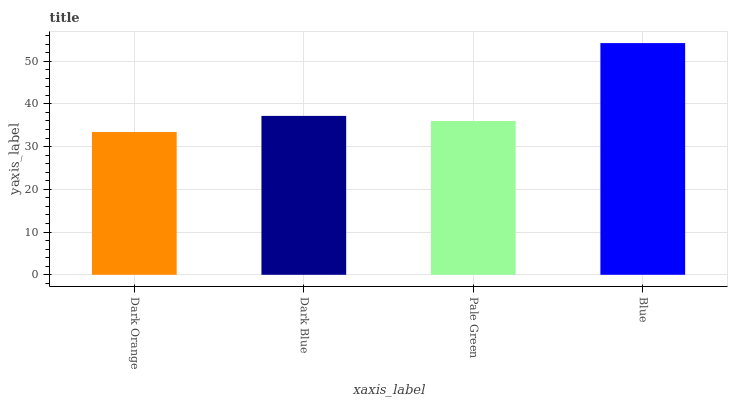Is Dark Orange the minimum?
Answer yes or no. Yes. Is Blue the maximum?
Answer yes or no. Yes. Is Dark Blue the minimum?
Answer yes or no. No. Is Dark Blue the maximum?
Answer yes or no. No. Is Dark Blue greater than Dark Orange?
Answer yes or no. Yes. Is Dark Orange less than Dark Blue?
Answer yes or no. Yes. Is Dark Orange greater than Dark Blue?
Answer yes or no. No. Is Dark Blue less than Dark Orange?
Answer yes or no. No. Is Dark Blue the high median?
Answer yes or no. Yes. Is Pale Green the low median?
Answer yes or no. Yes. Is Blue the high median?
Answer yes or no. No. Is Dark Orange the low median?
Answer yes or no. No. 